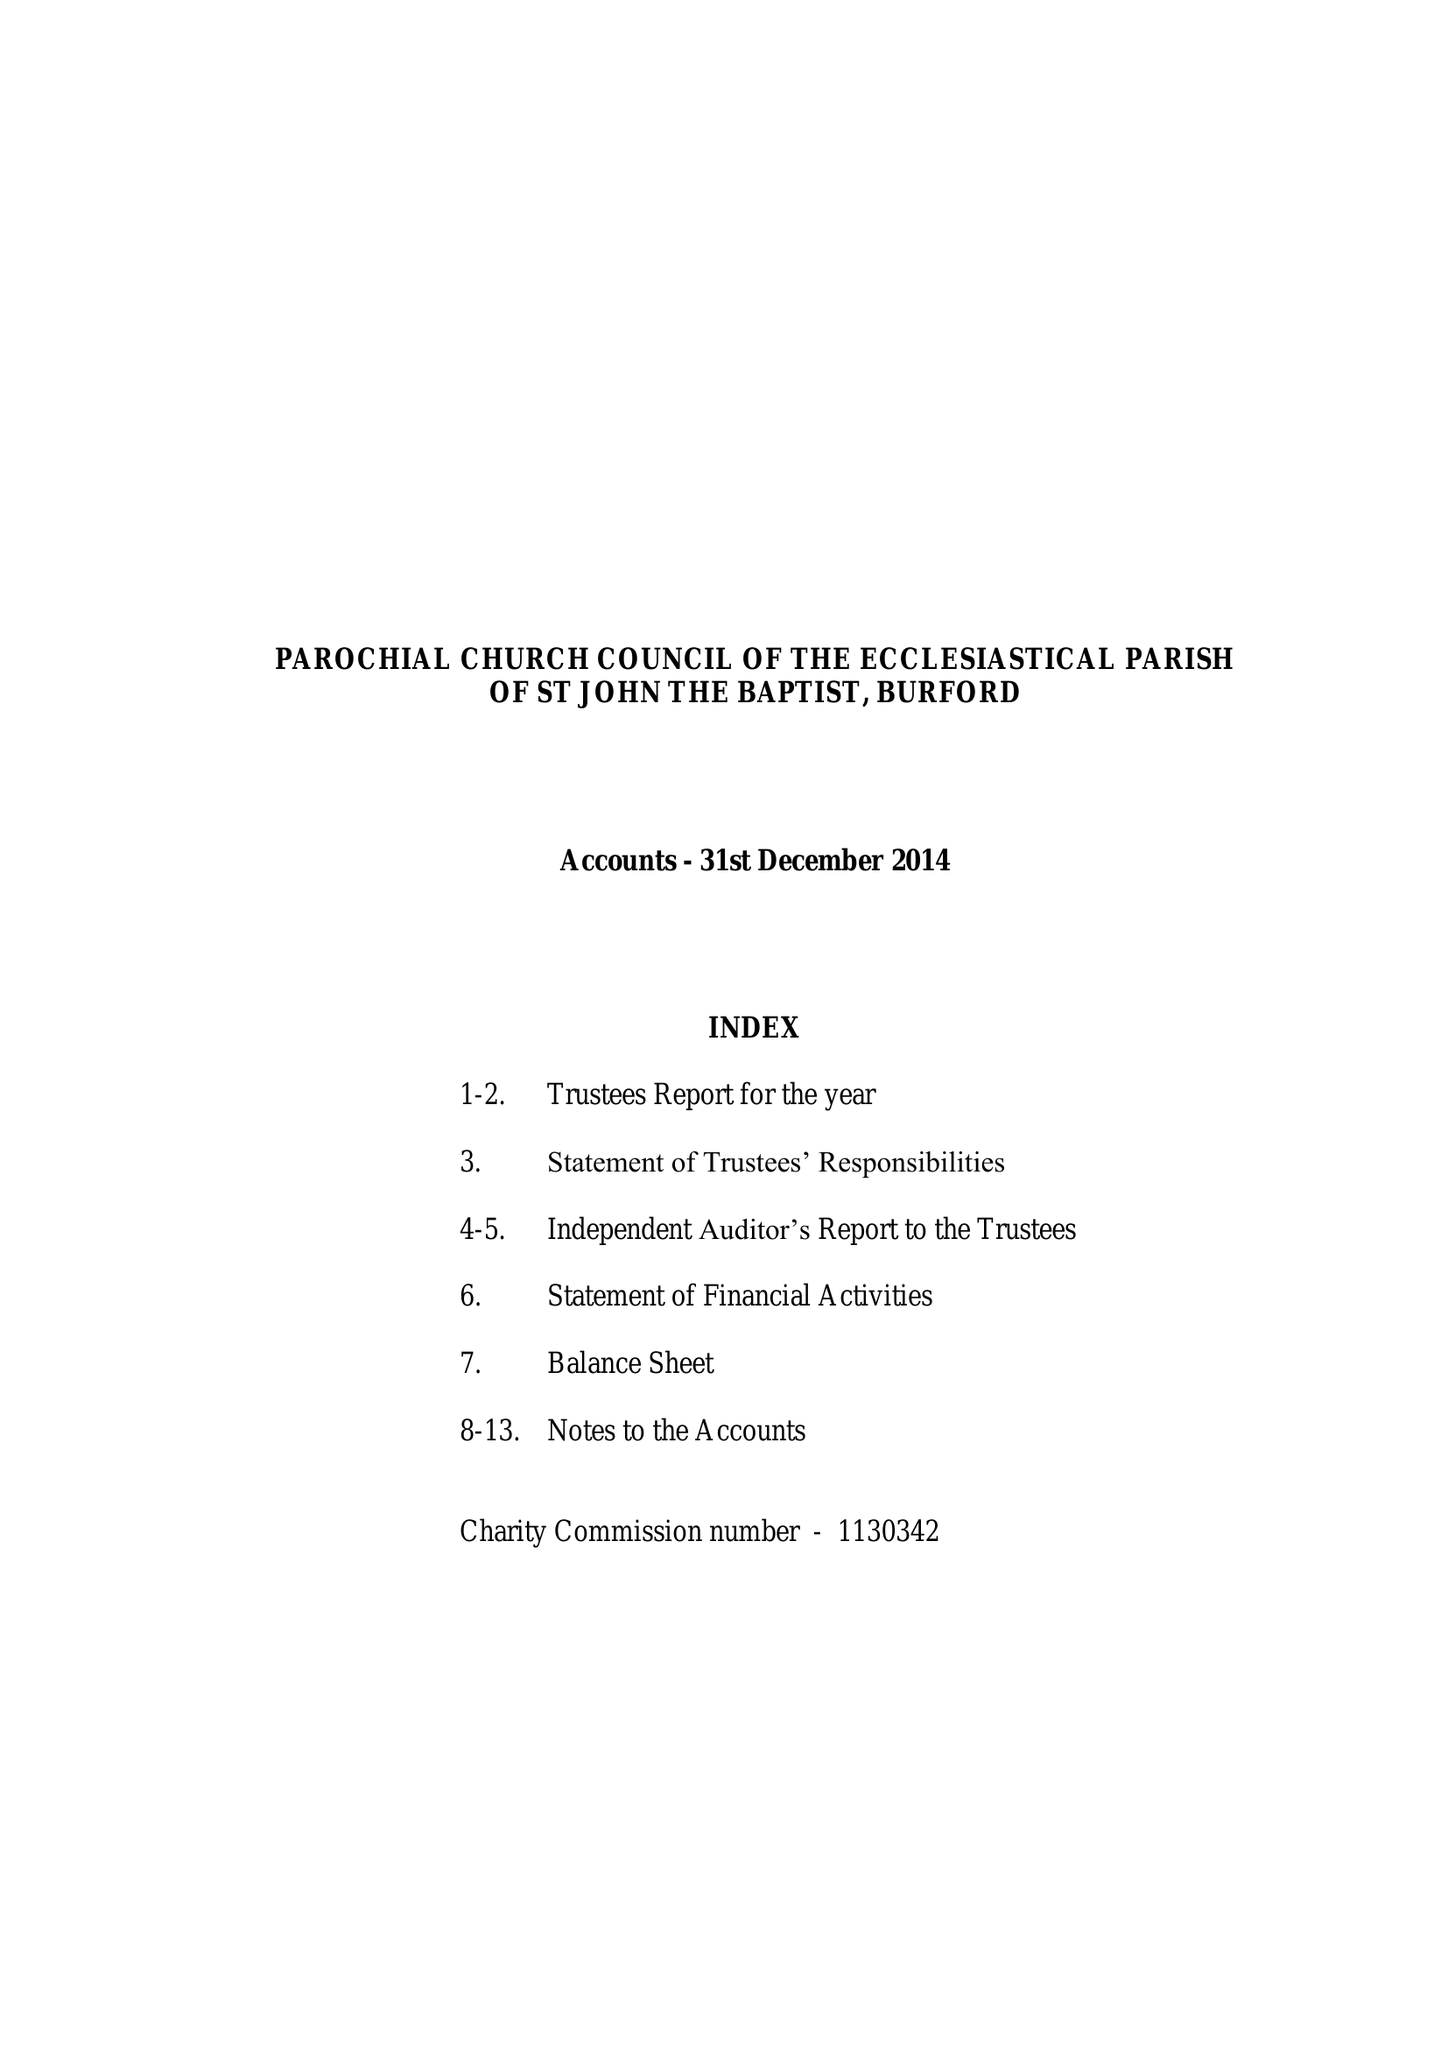What is the value for the address__postcode?
Answer the question using a single word or phrase. OX18 4RZ 